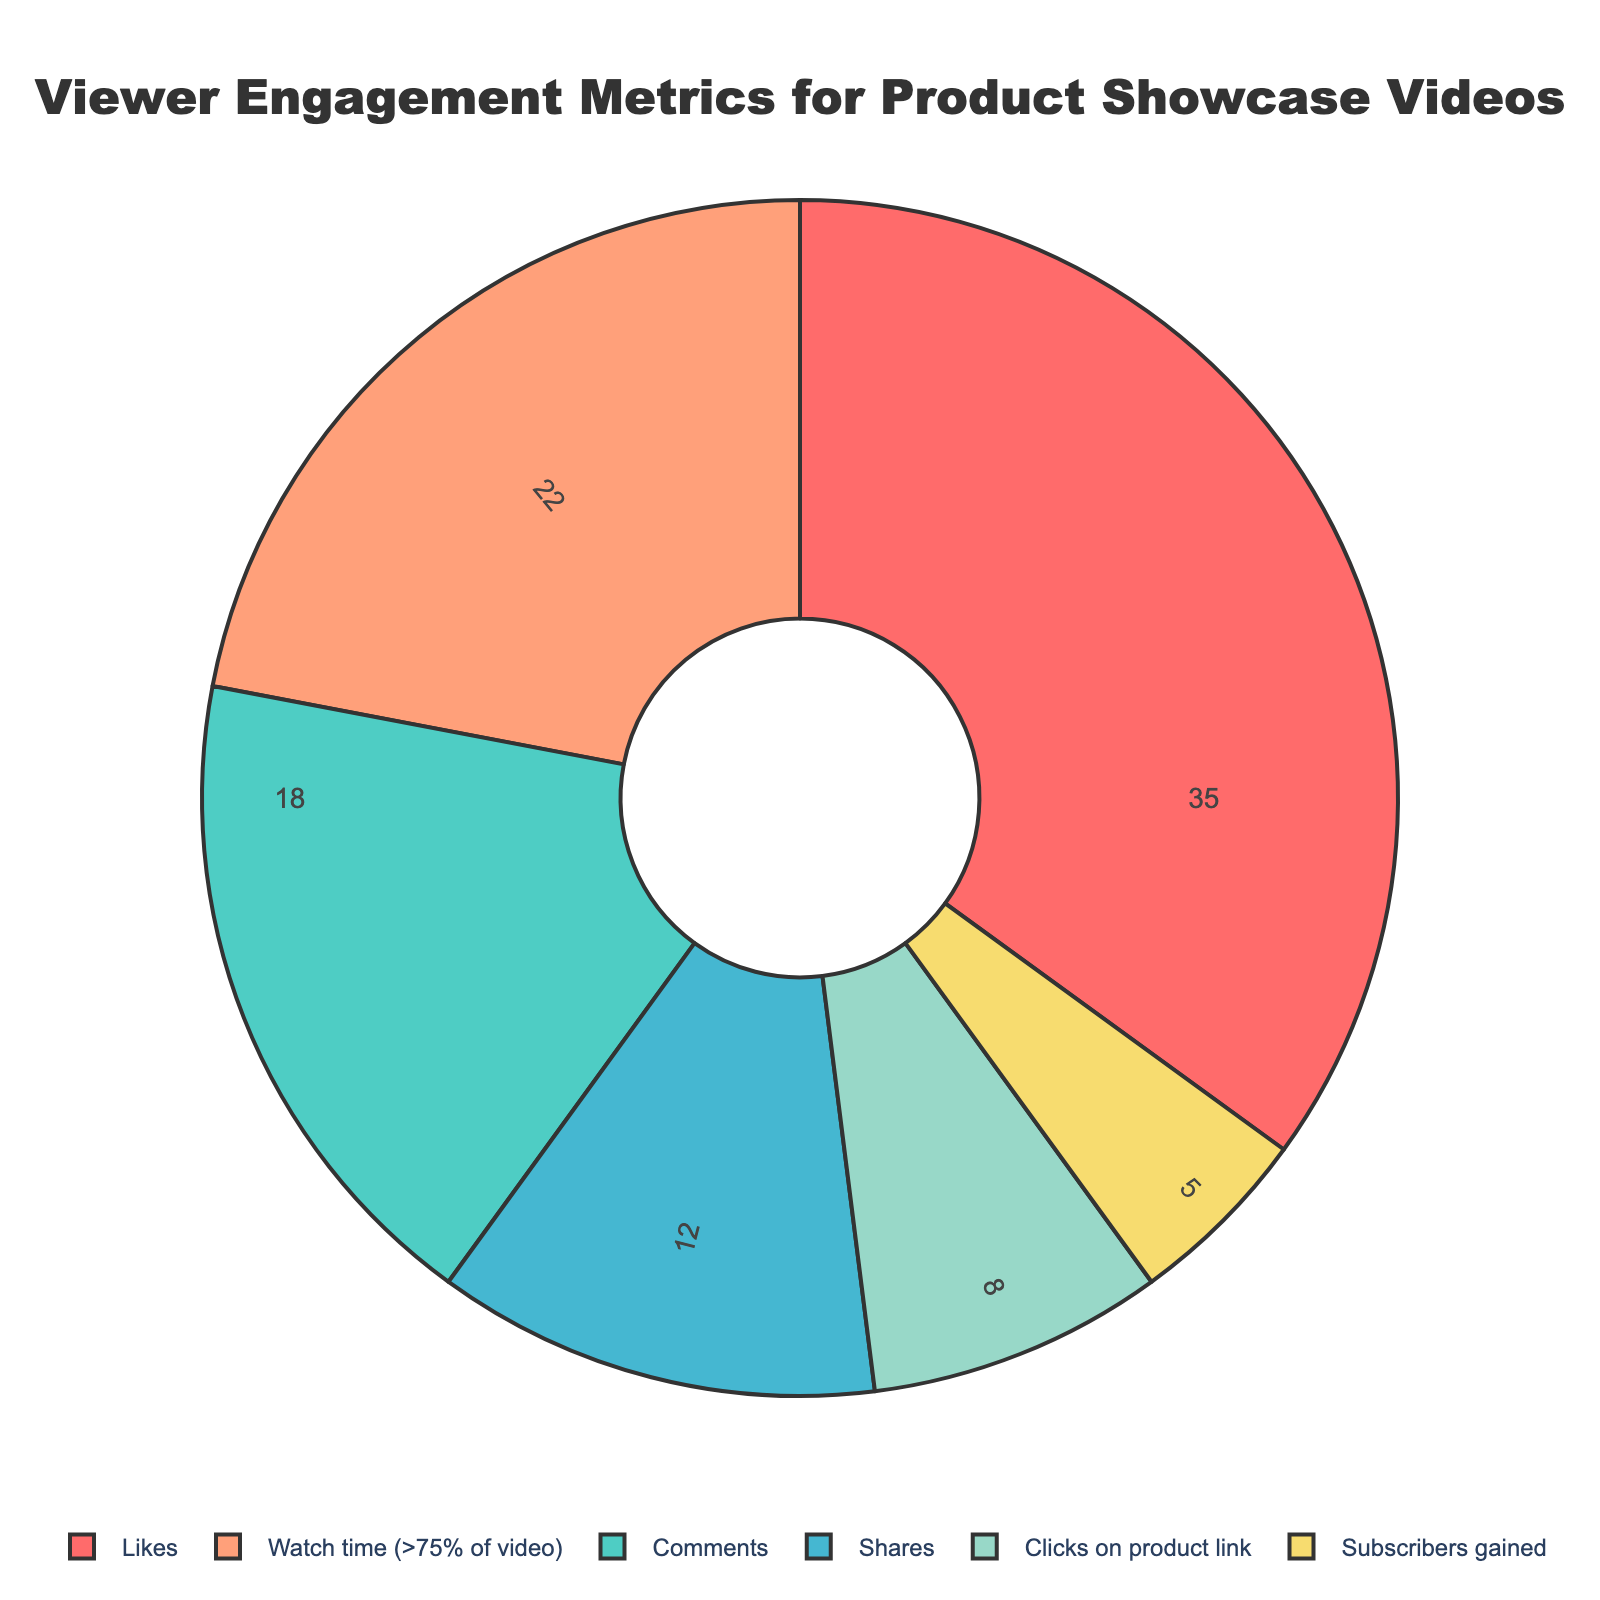What percentage of viewer engagement is attributed to comments? Simply look at the pie chart for the segment labeled "Comments". The pie chart shows the percentage for each metric directly.
Answer: 18% Which metric contributes the most to viewer engagement? The largest segment of the pie chart represents the metric that contributes the most. The "Likes" segment appears largest.
Answer: Likes How much higher is the percentage for "Likes" compared to "Shares"? Subtract the percentage for "Shares" from that of "Likes". "Likes" is 35% and "Shares" is 12%, so the difference is 35% - 12% = 23%.
Answer: 23% What is the total percentage of engagement attributed to "Comments" and "Watch time (>75% of video)" combined? Sum up the percentages for "Comments" and "Watch time (>75% of video)". "Comments" is 18% and "Watch time (>75% of video)" is 22%. 18% + 22% = 40%.
Answer: 40% Which metric has the smallest contribution to viewer engagement? The smallest segment of the pie chart represents the metric with the smallest contribution. "Subscribers gained" appears to be the smallest.
Answer: Subscribers gained Between "Clicks on product link" and "Shares", which has a higher engagement percentage, and by how much? Compare the percentages for "Clicks on product link" and "Shares". "Shares" is 12% and "Clicks on product link" is 8%. The difference is 12% - 8% = 4%.
Answer: Shares, by 4% If we combine the percentages for "Subscribers gained" and "Clicks on product link", what is the total? Sum up the percentages for "Subscribers gained" and "Clicks on product link". "Subscribers gained" is 5% and "Clicks on product link" is 8%. 5% + 8% = 13%.
Answer: 13% What is the combined percentage of the top three engagement metrics? Identify the top three metrics: "Likes" (35%), "Watch time (>75% of video)" (22%), and "Comments" (18%). Add them up: 35% + 22% + 18% = 75%.
Answer: 75% Explain why "Subscribers gained" has the least impact on engagement compared to the other metrics. According to the pie chart, "Subscribers gained" has the smallest segment, indicating it has the lowest percentage of viewer engagement at 5%. This suggests fewer viewers are subscribing after watching the product showcase videos compared to engaging in other ways.
Answer: It has the lowest percentage, 5% 